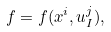Convert formula to latex. <formula><loc_0><loc_0><loc_500><loc_500>f = f ( x ^ { i } , u _ { I } ^ { j } ) ,</formula> 